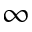<formula> <loc_0><loc_0><loc_500><loc_500>\infty</formula> 